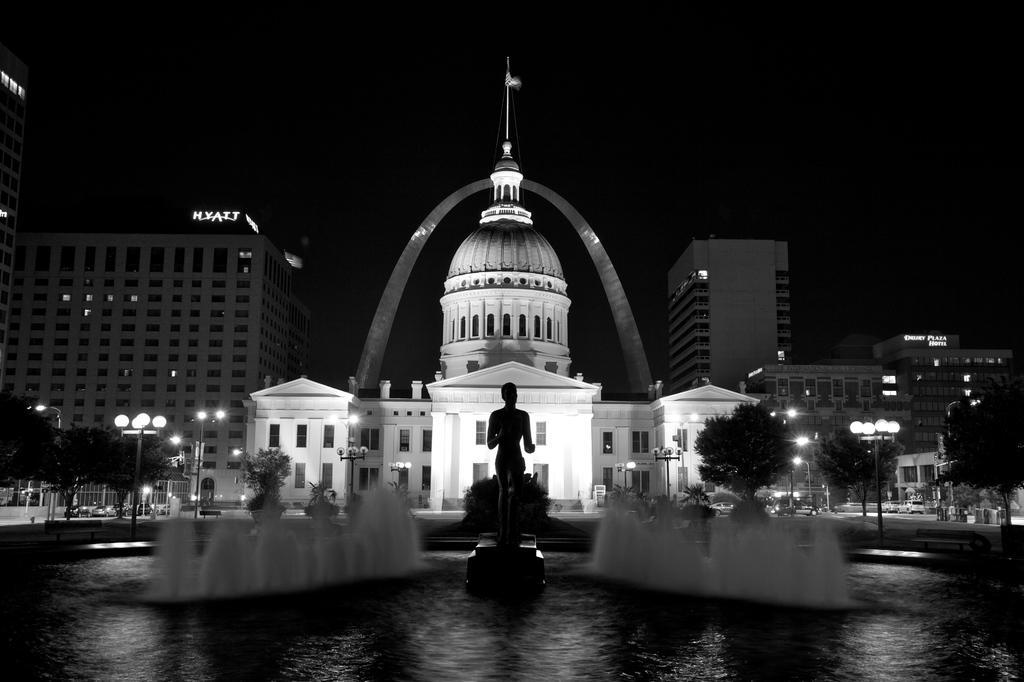Please provide a concise description of this image. In the center of the image there is a statue. There are fountains. In the background of the image there are light poles, trees, metal fence, buildings. There are cars on the road. At the top of the image there is sky. 